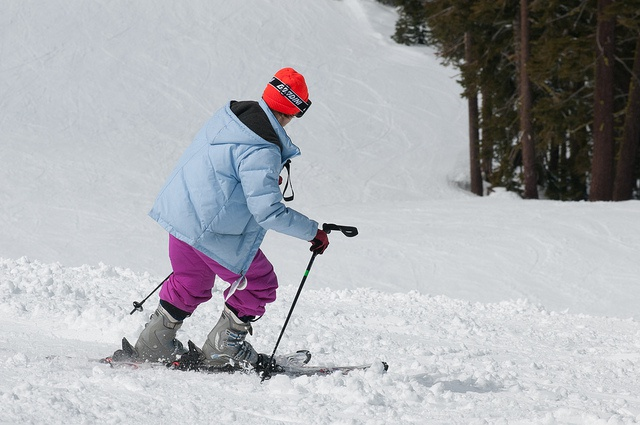Describe the objects in this image and their specific colors. I can see people in lightgray, lightblue, gray, and darkgray tones and skis in lightgray, darkgray, gray, and black tones in this image. 